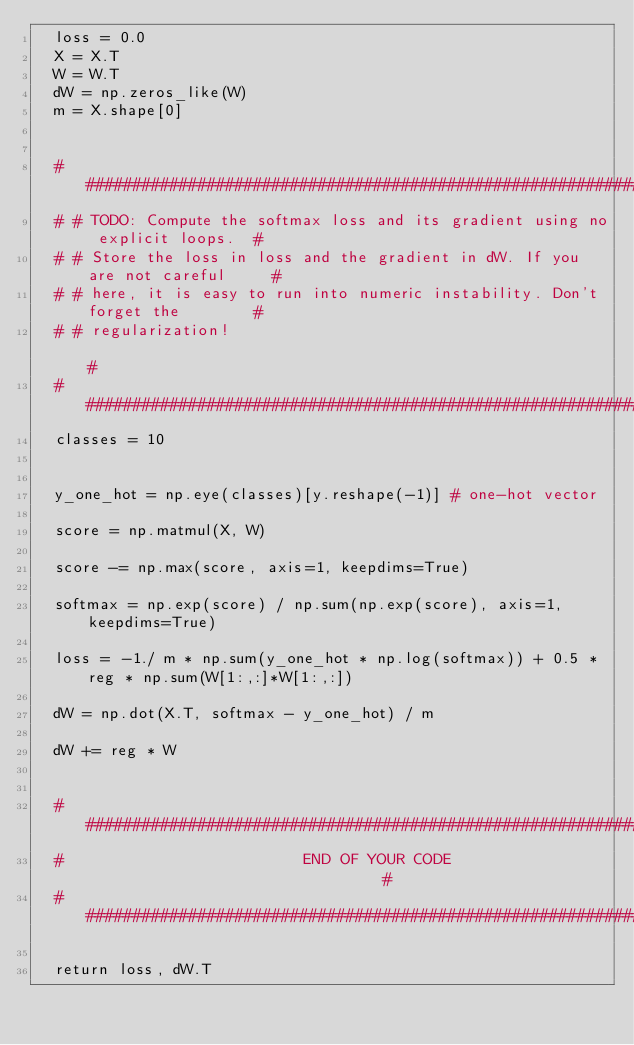Convert code to text. <code><loc_0><loc_0><loc_500><loc_500><_Python_>  loss = 0.0
  X = X.T
  W = W.T
  dW = np.zeros_like(W)
  m = X.shape[0]

  
  # #############################################################################
  # # TODO: Compute the softmax loss and its gradient using no explicit loops.  #
  # # Store the loss in loss and the gradient in dW. If you are not careful     #
  # # here, it is easy to run into numeric instability. Don't forget the        #
  # # regularization!                                                           #
  # #############################################################################
  classes = 10
  
  
  y_one_hot = np.eye(classes)[y.reshape(-1)] # one-hot vector
  
  score = np.matmul(X, W)
  
  score -= np.max(score, axis=1, keepdims=True)
  
  softmax = np.exp(score) / np.sum(np.exp(score), axis=1, keepdims=True)
  
  loss = -1./ m * np.sum(y_one_hot * np.log(softmax)) + 0.5 * reg * np.sum(W[1:,:]*W[1:,:])

  dW = np.dot(X.T, softmax - y_one_hot) / m
  
  dW += reg * W
  
  
  #############################################################################
  #                          END OF YOUR CODE                                 #
  #############################################################################

  return loss, dW.T
</code> 